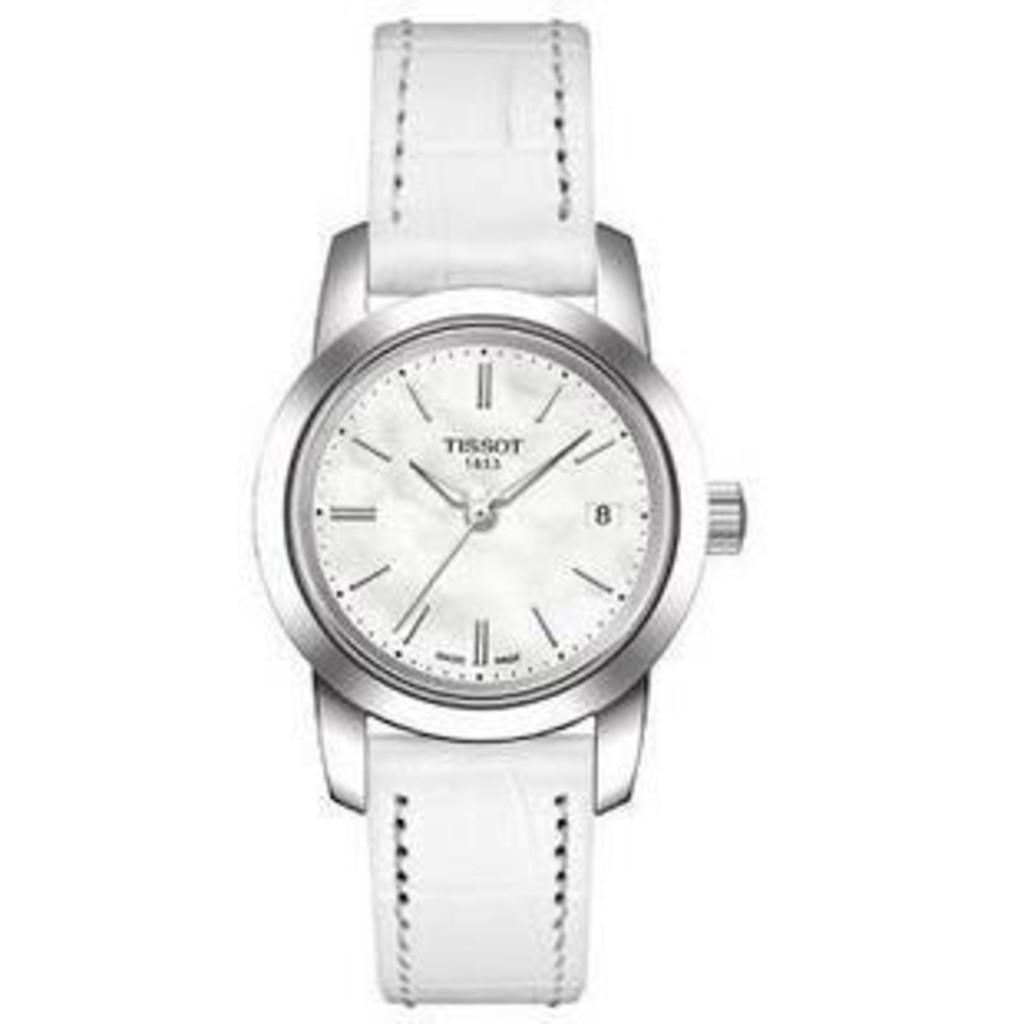<image>
Describe the image concisely. A silver Tissot watch with a white leather band. 